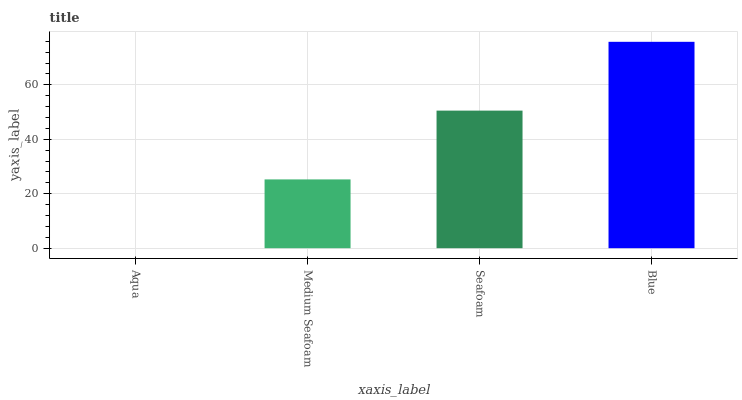Is Aqua the minimum?
Answer yes or no. Yes. Is Blue the maximum?
Answer yes or no. Yes. Is Medium Seafoam the minimum?
Answer yes or no. No. Is Medium Seafoam the maximum?
Answer yes or no. No. Is Medium Seafoam greater than Aqua?
Answer yes or no. Yes. Is Aqua less than Medium Seafoam?
Answer yes or no. Yes. Is Aqua greater than Medium Seafoam?
Answer yes or no. No. Is Medium Seafoam less than Aqua?
Answer yes or no. No. Is Seafoam the high median?
Answer yes or no. Yes. Is Medium Seafoam the low median?
Answer yes or no. Yes. Is Medium Seafoam the high median?
Answer yes or no. No. Is Seafoam the low median?
Answer yes or no. No. 